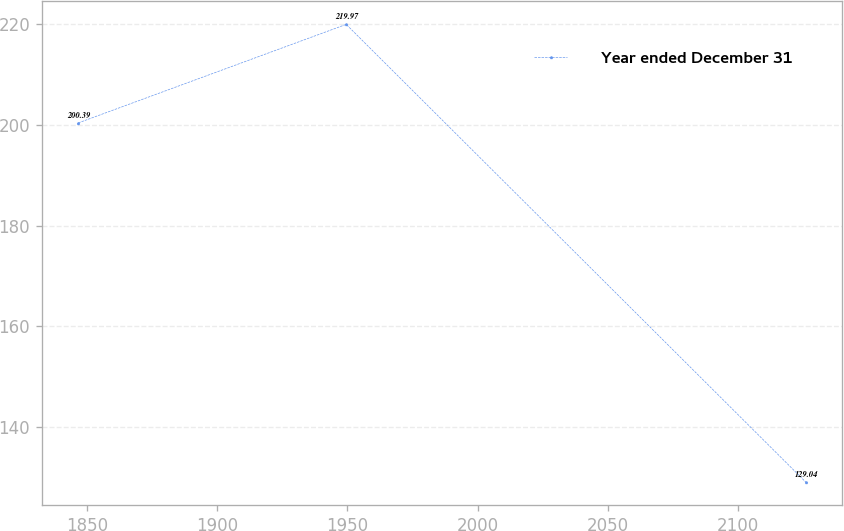<chart> <loc_0><loc_0><loc_500><loc_500><line_chart><ecel><fcel>Year ended December 31<nl><fcel>1846.64<fcel>200.39<nl><fcel>1949.55<fcel>219.97<nl><fcel>2126<fcel>129.04<nl></chart> 